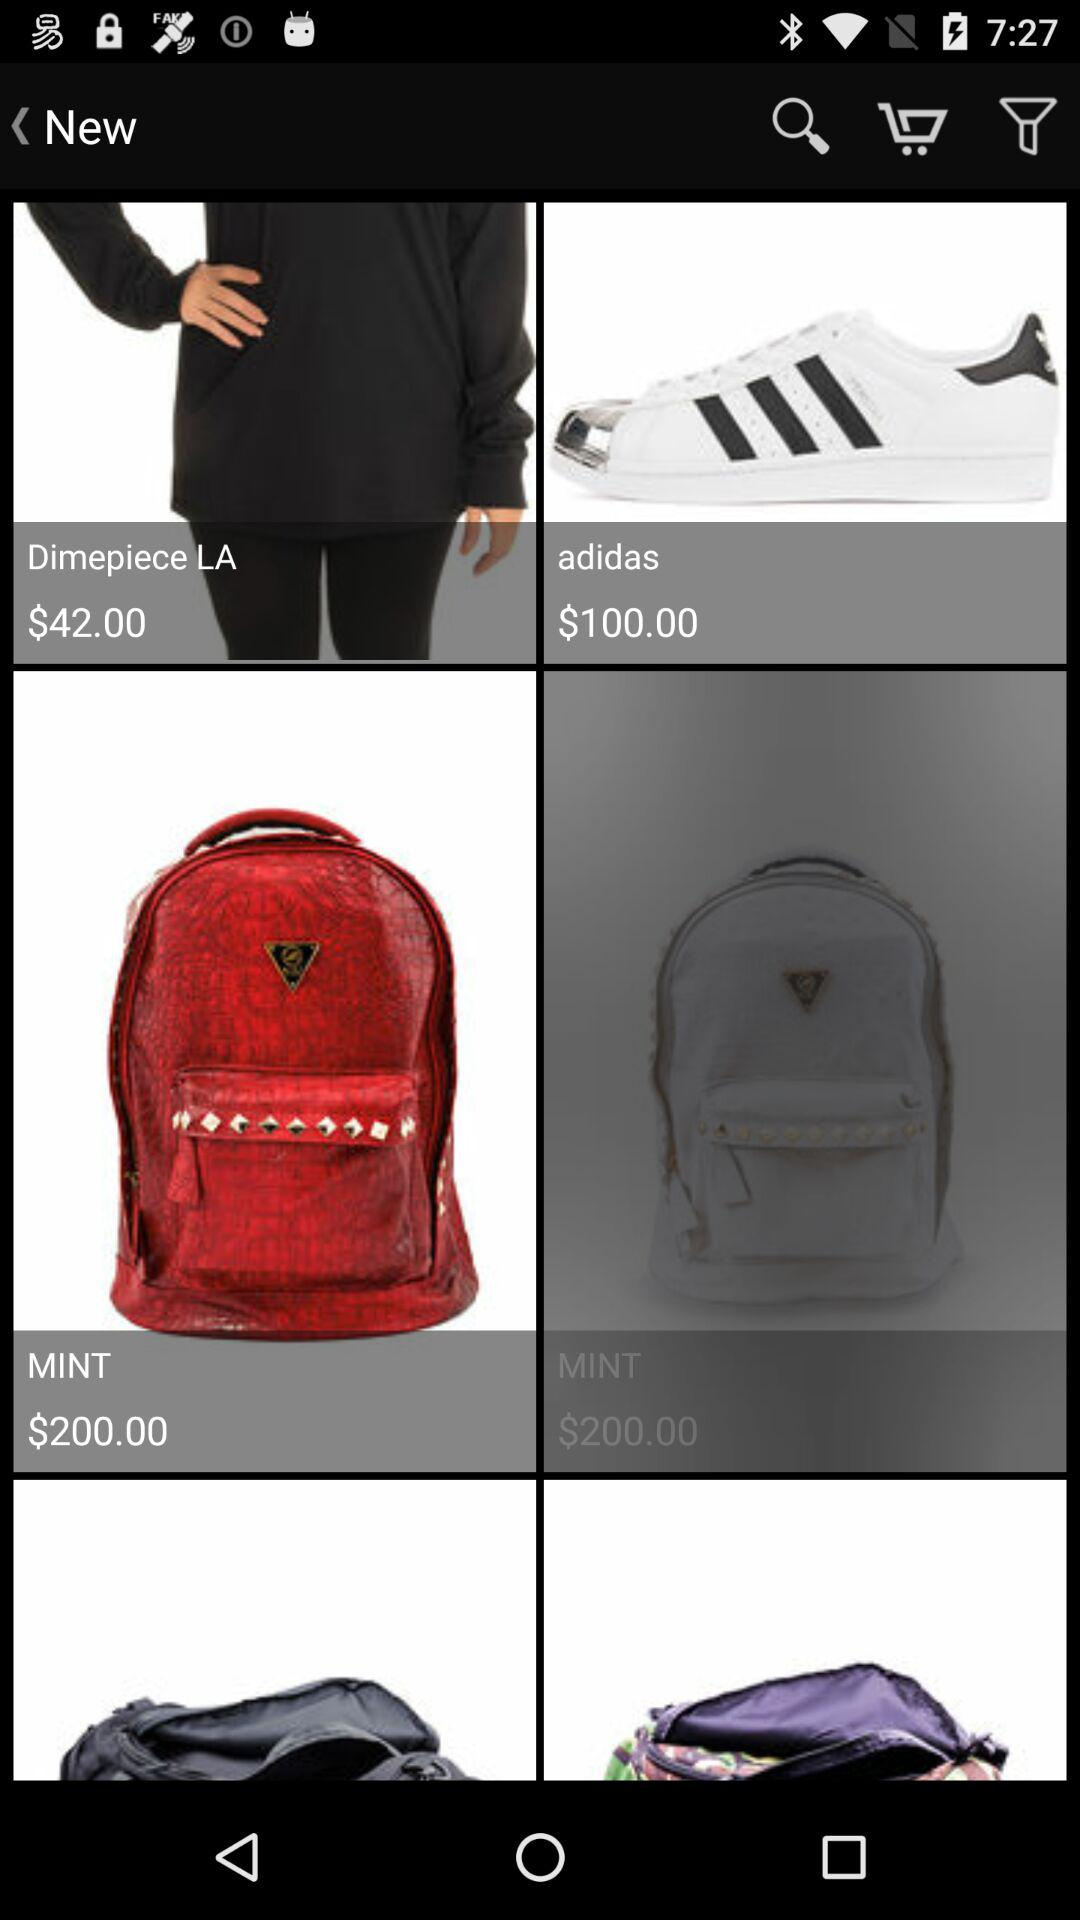What is the "adidas" price? The "adidas" price is $100. 